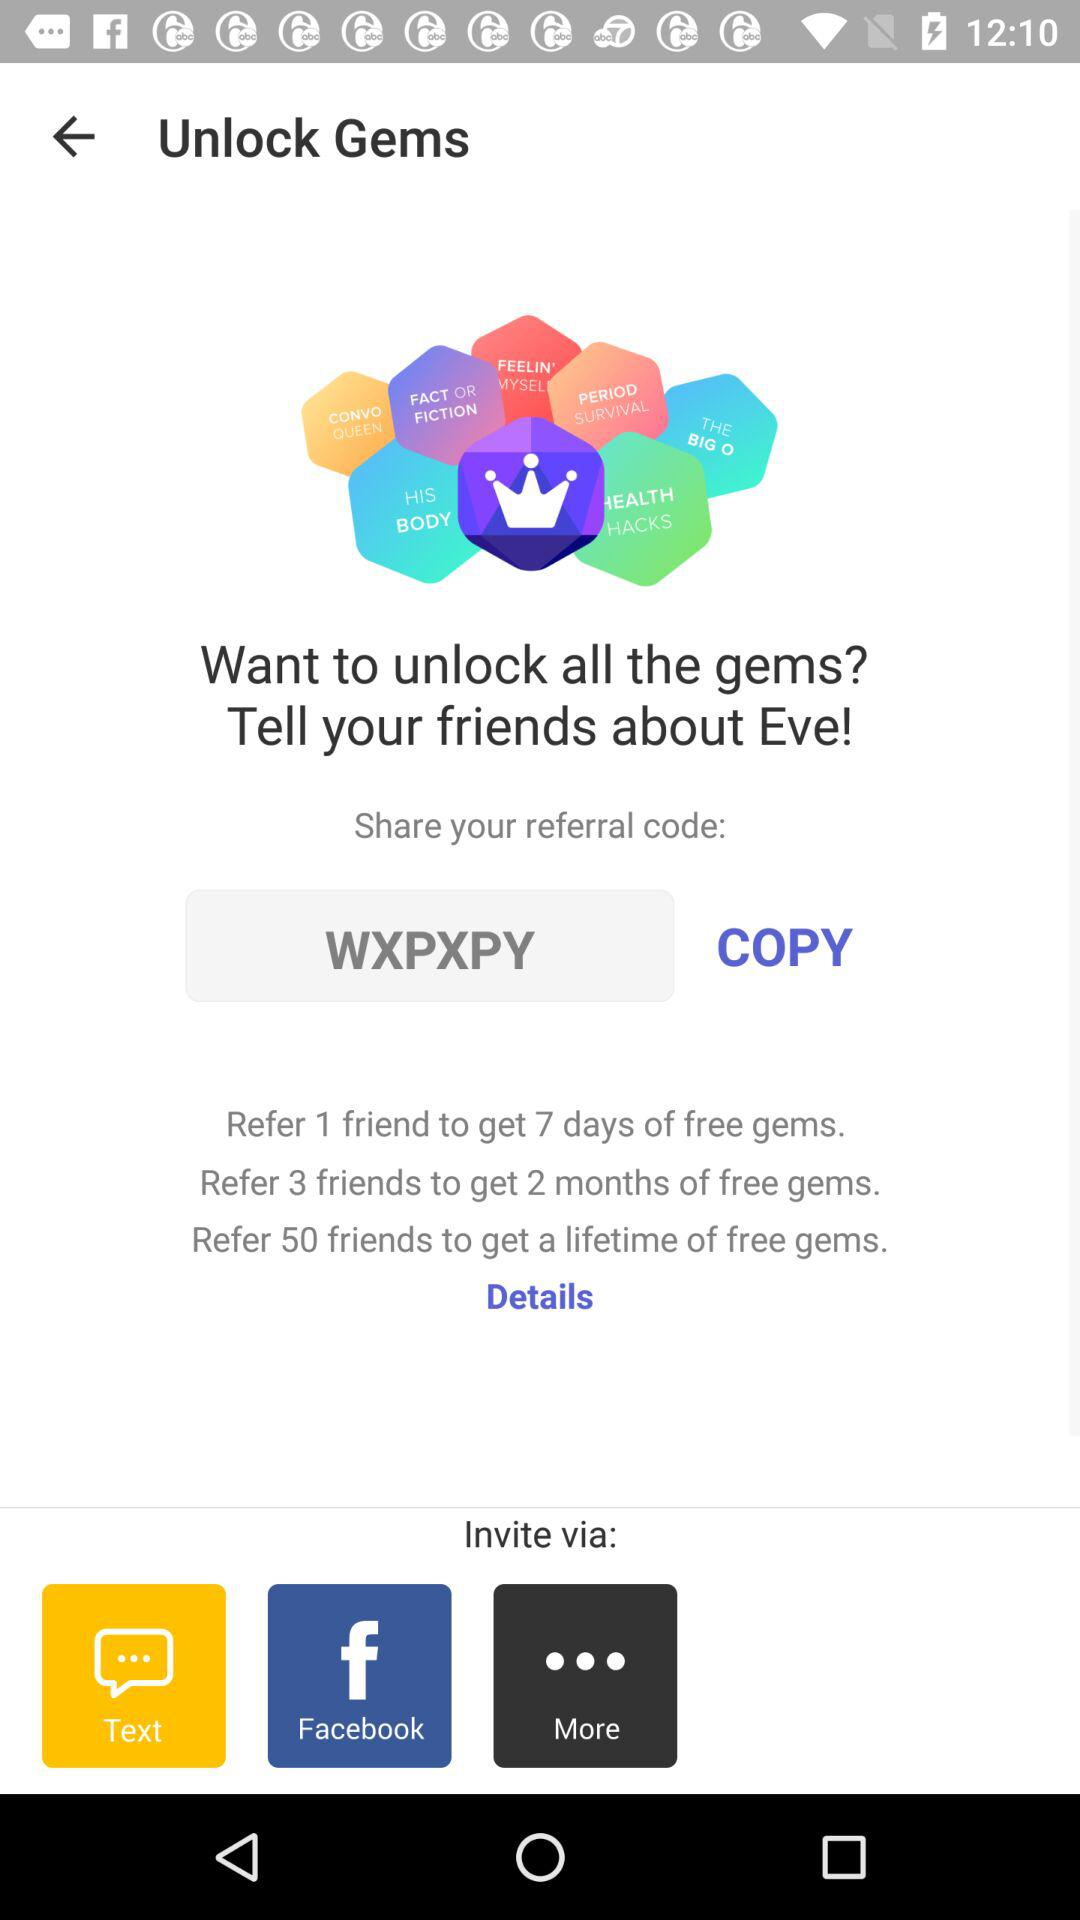How many days of free gems are offered for referring 3 friends?
Answer the question using a single word or phrase. 2 months 